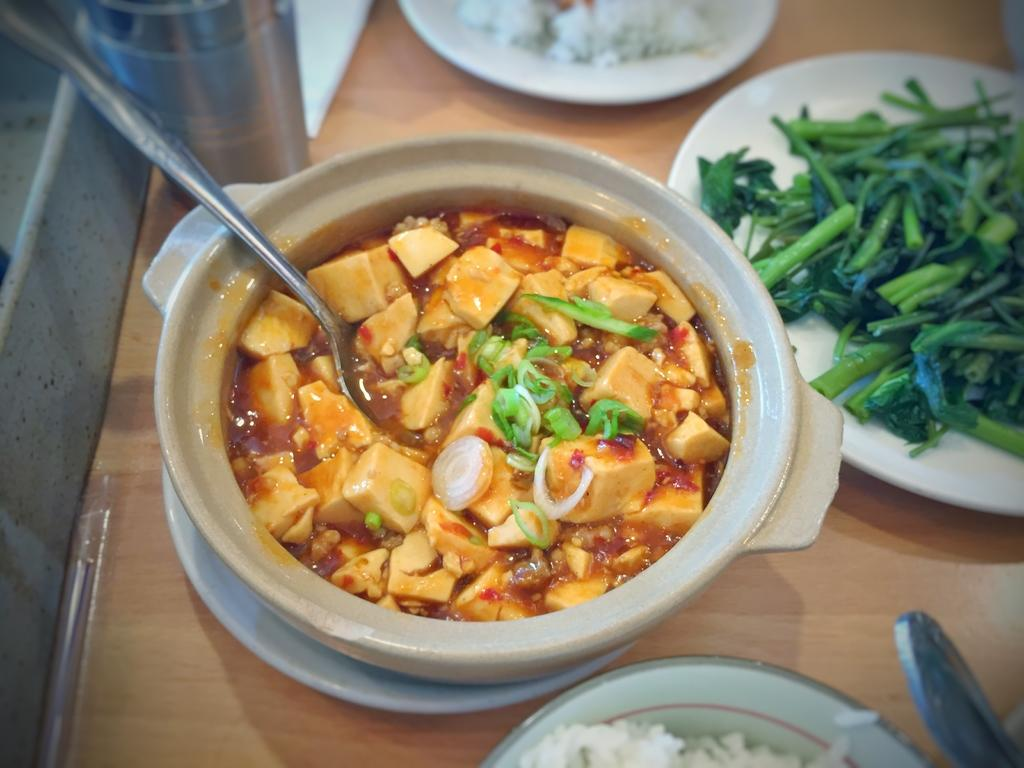What type of containers are holding food items in the image? There are bowls and plates holding food items in the image. Where are the food items located? The food items are on a table. What else can be seen on the table in the image? There is a glass on the table. What type of berry is growing on the ground in the image? There is no berry or ground present in the image; it features food items on bowls, plates, and a glass on a table. 